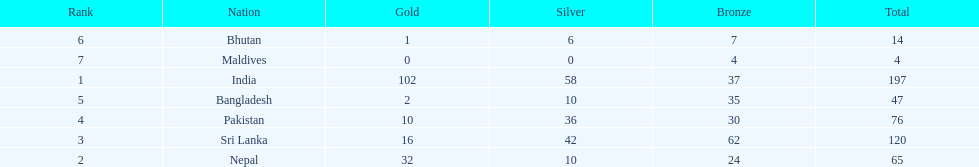What was the only nation to win less than 10 medals total? Maldives. 